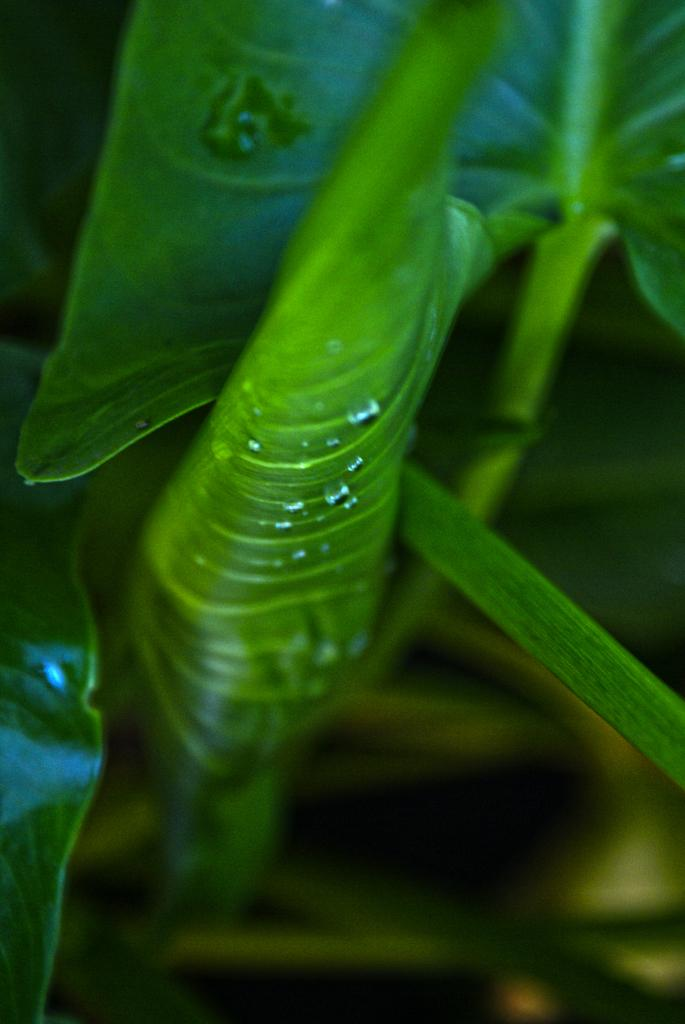What type of plant is visible in the image? The image contains leaves of a plant, but it does not specify the type of plant. Can you describe the leaves in the image? The leaves in the image are likely green and may have various shapes and sizes depending on the plant. What is the primary color of the leaves in the image? The primary color of the leaves in the image is green. What type of bird is attacking the leaves in the image? There are no birds present in the image, and the leaves are not being attacked. 